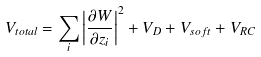Convert formula to latex. <formula><loc_0><loc_0><loc_500><loc_500>V _ { t o t a l } = \sum _ { i } \left | { \frac { \partial W } { \partial z _ { i } } } \right | ^ { 2 } + V _ { D } + V _ { s o f t } + V _ { R C }</formula> 